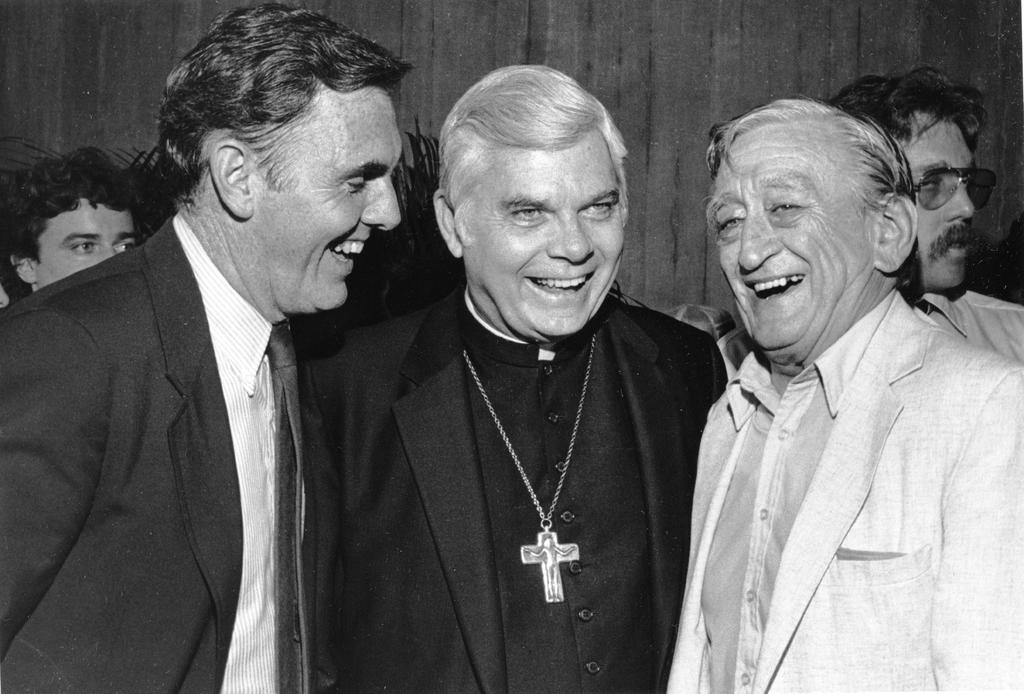What is the color scheme of the image? The image is black and white. What can be seen in the image? There are people standing in the image. What is visible in the background of the image? There is a wall visible in the background of the image. Can you tell me how many wheels are visible in the image? There are no wheels present in the image. What emotion do the people in the image seem to be expressing? The provided facts do not give any information about the emotions of the people in the image. 